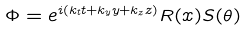Convert formula to latex. <formula><loc_0><loc_0><loc_500><loc_500>\Phi = e ^ { i ( k _ { t } t + k _ { y } y + k _ { z } z ) } R ( x ) S ( \theta )</formula> 